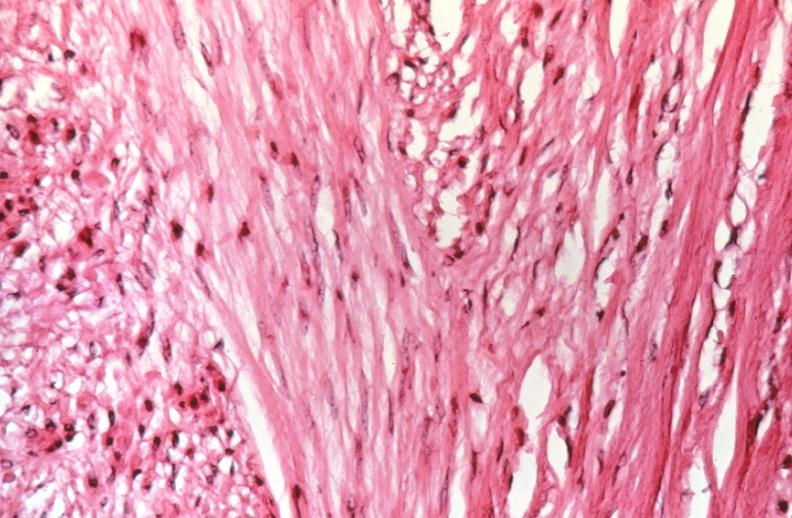does band constriction in skin above ankle of infant show uterus, leiomyomas?
Answer the question using a single word or phrase. No 